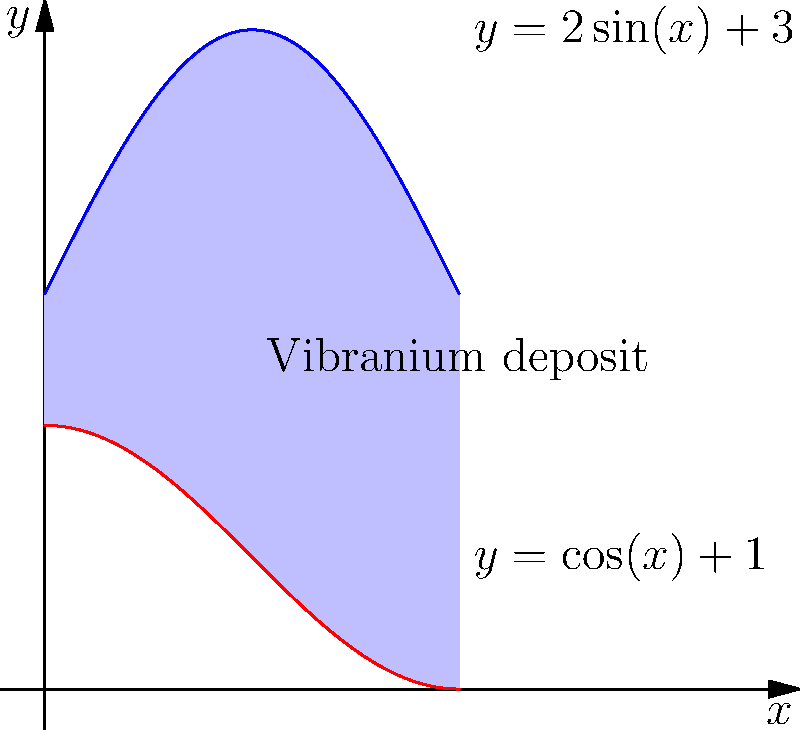In Wakanda, a newly discovered vibranium deposit has an irregular shape bounded by the curves $y=2\sin(x)+3$ and $y=\cos(x)+1$ from $x=0$ to $x=\pi$. As a S.H.I.E.L.D. agent tasked with assessing Wakanda's resources, calculate the area of this vibranium deposit using integration. To find the area of the region bounded by two curves, we need to integrate the difference between the upper and lower functions over the given interval. Here's how we can solve this step-by-step:

1) The upper curve is $y=2\sin(x)+3$
2) The lower curve is $y=\cos(x)+1$
3) The area is given by the integral of the difference between these functions from 0 to π:

   $$A = \int_0^\pi [(2\sin(x)+3) - (\cos(x)+1)] dx$$

4) Simplify the integrand:
   $$A = \int_0^\pi [2\sin(x) - \cos(x) + 2] dx$$

5) Integrate each term:
   $$A = [-2\cos(x) - \sin(x) + 2x]_0^\pi$$

6) Evaluate the antiderivative at the limits:
   $$A = [(-2\cos(\pi) - \sin(\pi) + 2\pi) - (-2\cos(0) - \sin(0) + 0)]$$

7) Simplify:
   $$A = [2 - 0 + 2\pi - (-2 - 0 + 0)]$$
   $$A = 2\pi + 4$$

Therefore, the area of the vibranium deposit is $2\pi + 4$ square units.
Answer: $2\pi + 4$ square units 